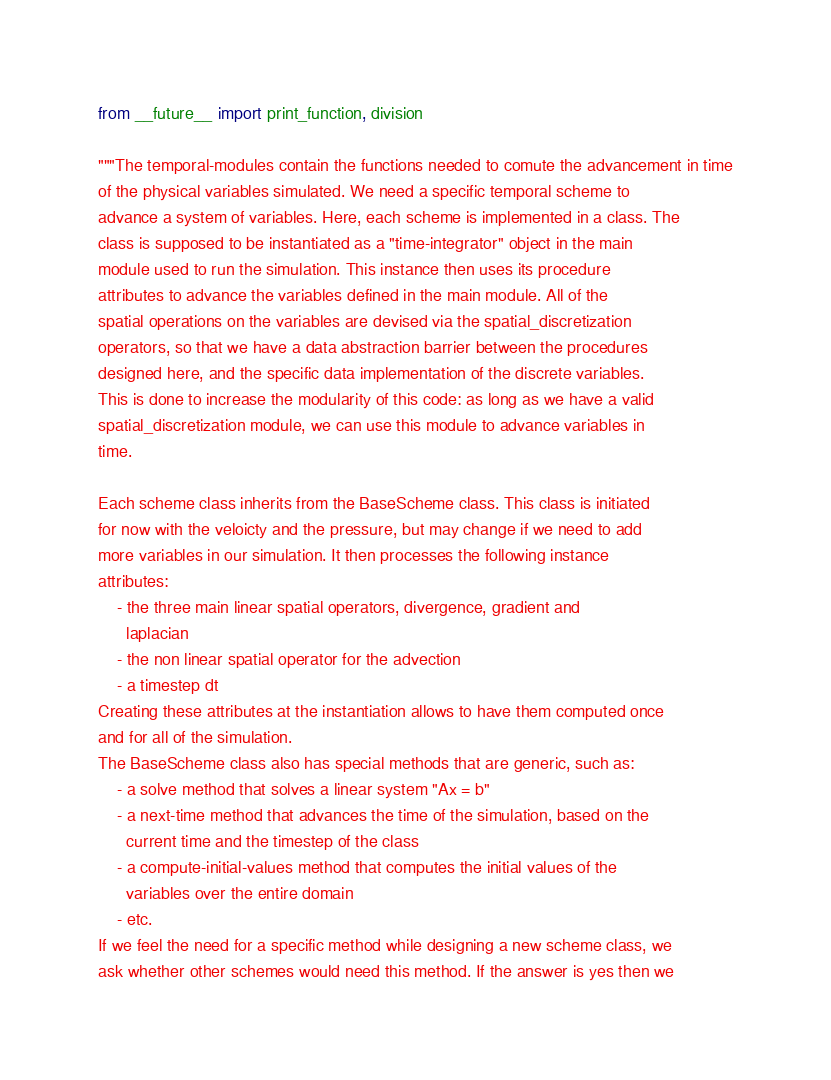<code> <loc_0><loc_0><loc_500><loc_500><_Python_>from __future__ import print_function, division

"""The temporal-modules contain the functions needed to comute the advancement in time
of the physical variables simulated. We need a specific temporal scheme to
advance a system of variables. Here, each scheme is implemented in a class. The
class is supposed to be instantiated as a "time-integrator" object in the main
module used to run the simulation. This instance then uses its procedure
attributes to advance the variables defined in the main module. All of the
spatial operations on the variables are devised via the spatial_discretization
operators, so that we have a data abstraction barrier between the procedures
designed here, and the specific data implementation of the discrete variables.
This is done to increase the modularity of this code: as long as we have a valid
spatial_discretization module, we can use this module to advance variables in
time.

Each scheme class inherits from the BaseScheme class. This class is initiated
for now with the veloicty and the pressure, but may change if we need to add
more variables in our simulation. It then processes the following instance
attributes:
    - the three main linear spatial operators, divergence, gradient and
      laplacian
    - the non linear spatial operator for the advection
    - a timestep dt
Creating these attributes at the instantiation allows to have them computed once
and for all of the simulation.
The BaseScheme class also has special methods that are generic, such as:
    - a solve method that solves a linear system "Ax = b"
    - a next-time method that advances the time of the simulation, based on the
      current time and the timestep of the class
    - a compute-initial-values method that computes the initial values of the
      variables over the entire domain
    - etc.
If we feel the need for a specific method while designing a new scheme class, we
ask whether other schemes would need this method. If the answer is yes then we</code> 